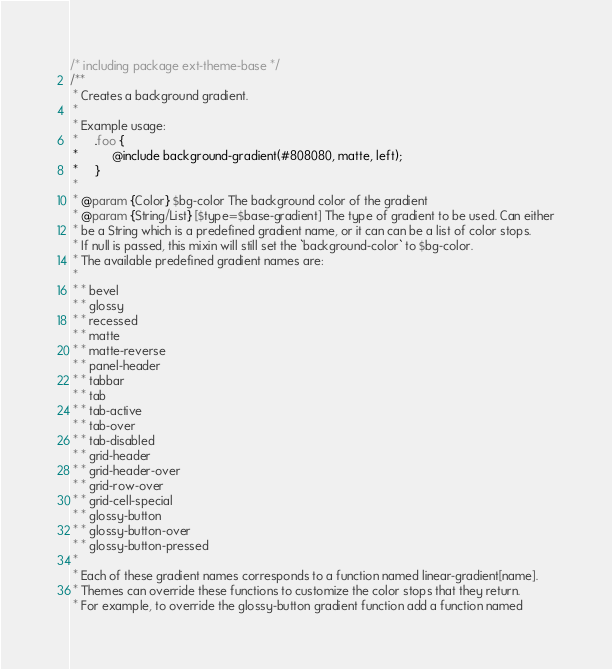<code> <loc_0><loc_0><loc_500><loc_500><_CSS_>/* including package ext-theme-base */
/**
 * Creates a background gradient.
 *
 * Example usage:
 *     .foo {
 *          @include background-gradient(#808080, matte, left);
 *     }
 *
 * @param {Color} $bg-color The background color of the gradient
 * @param {String/List} [$type=$base-gradient] The type of gradient to be used. Can either
 * be a String which is a predefined gradient name, or it can can be a list of color stops.
 * If null is passed, this mixin will still set the `background-color` to $bg-color.
 * The available predefined gradient names are:
 *
 * * bevel
 * * glossy
 * * recessed
 * * matte
 * * matte-reverse
 * * panel-header
 * * tabbar
 * * tab
 * * tab-active
 * * tab-over
 * * tab-disabled
 * * grid-header
 * * grid-header-over
 * * grid-row-over
 * * grid-cell-special
 * * glossy-button
 * * glossy-button-over
 * * glossy-button-pressed
 *
 * Each of these gradient names corresponds to a function named linear-gradient[name].
 * Themes can override these functions to customize the color stops that they return.
 * For example, to override the glossy-button gradient function add a function named</code> 